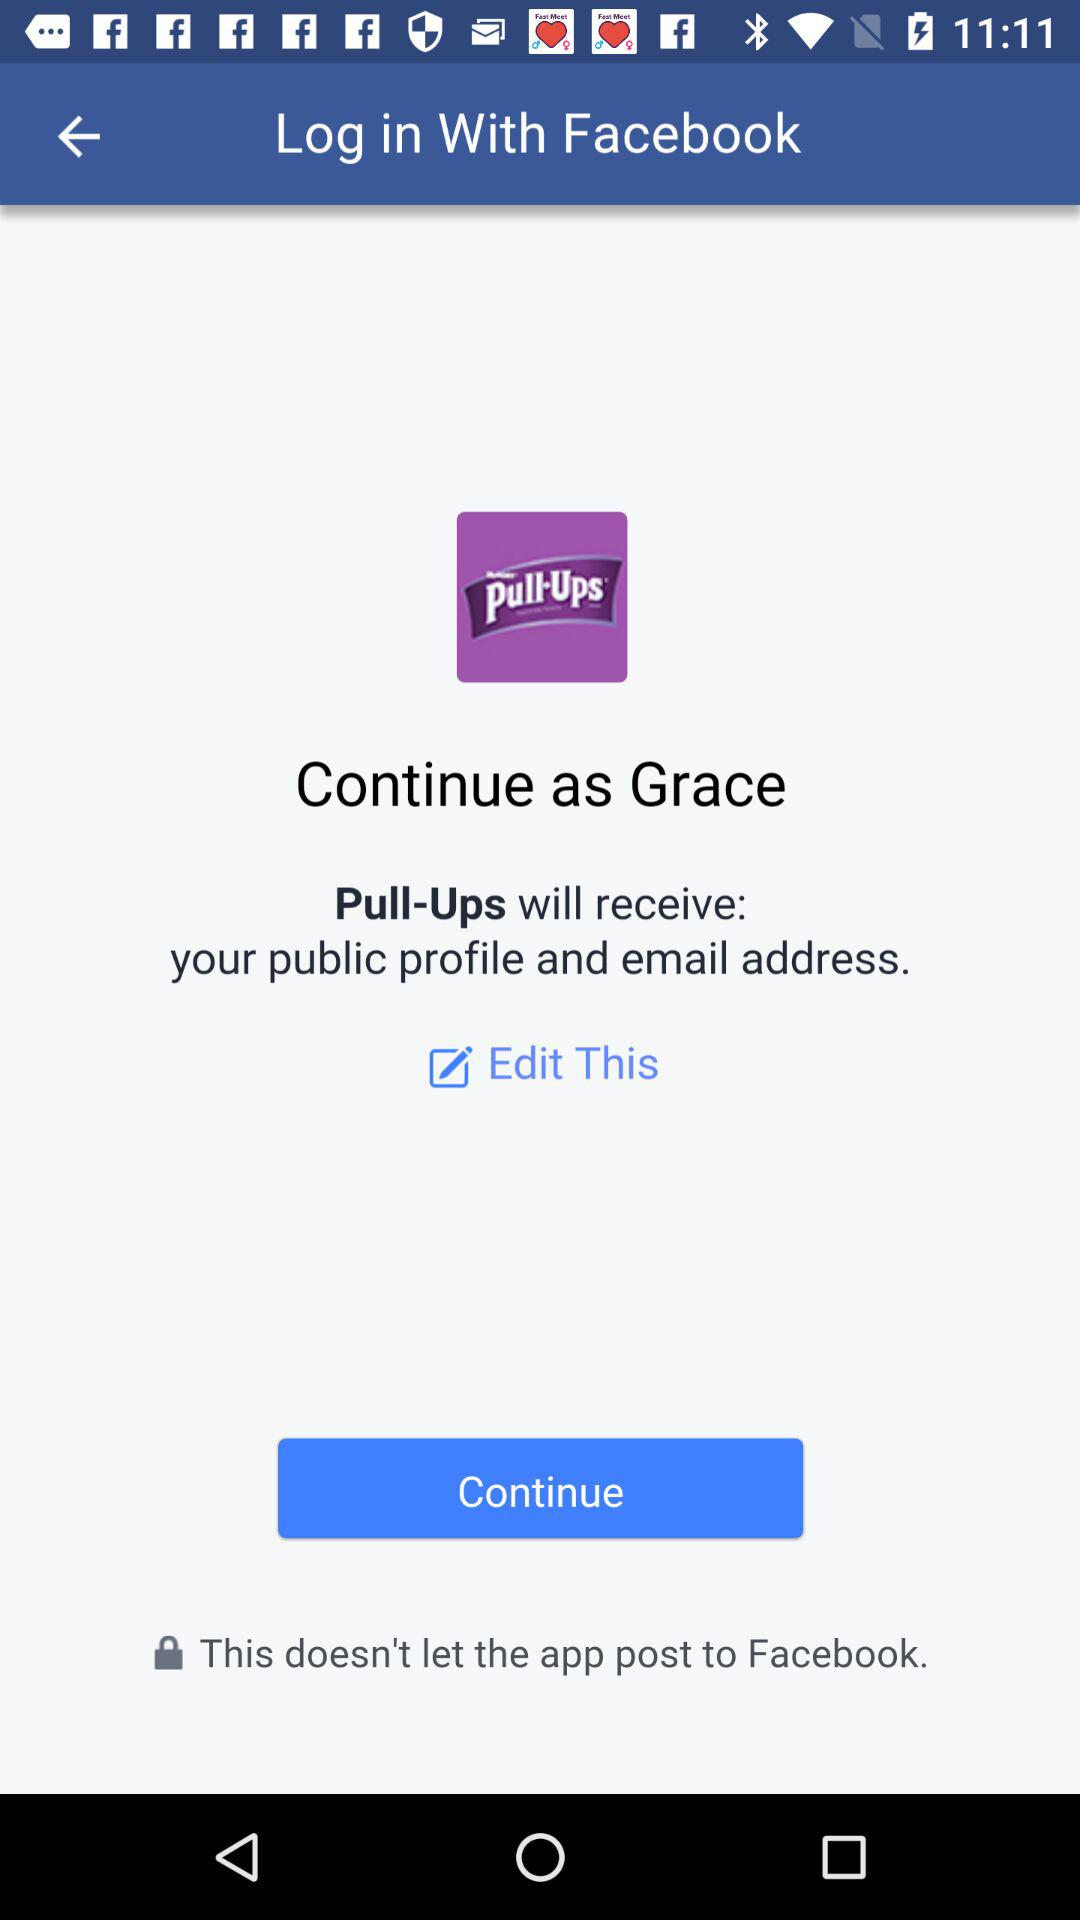What application is asking for permission? The application asking for permission is "Pull-Ups". 